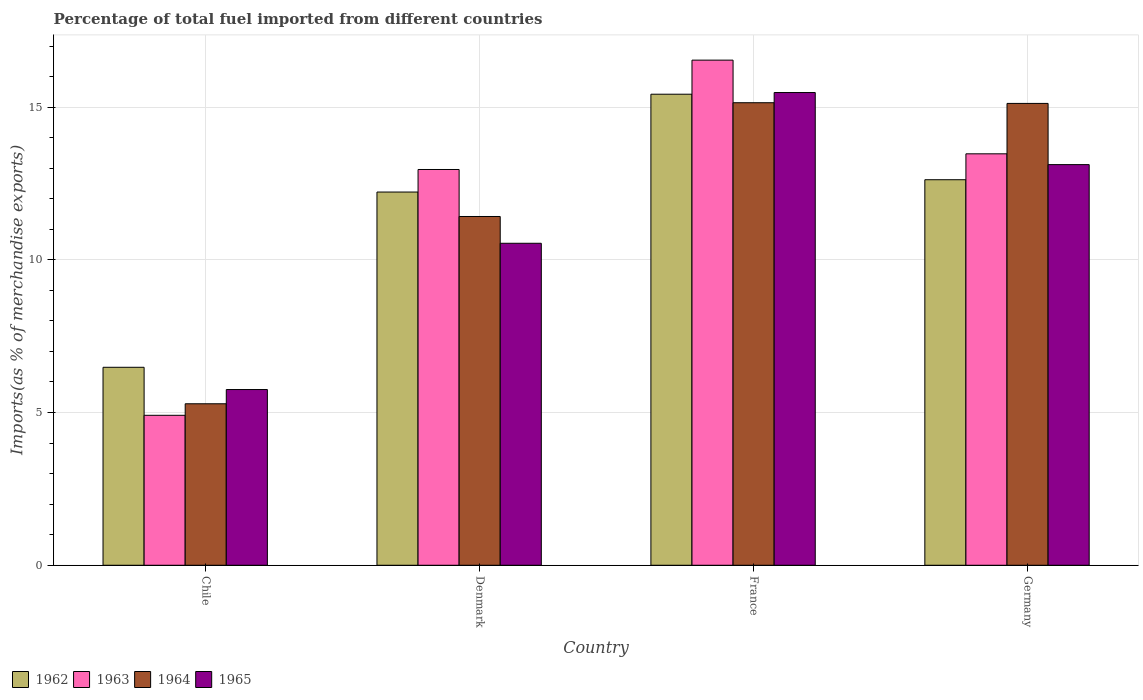How many different coloured bars are there?
Your answer should be compact. 4. How many groups of bars are there?
Provide a short and direct response. 4. How many bars are there on the 1st tick from the left?
Give a very brief answer. 4. What is the label of the 2nd group of bars from the left?
Your response must be concise. Denmark. What is the percentage of imports to different countries in 1965 in Chile?
Ensure brevity in your answer.  5.75. Across all countries, what is the maximum percentage of imports to different countries in 1964?
Provide a short and direct response. 15.14. Across all countries, what is the minimum percentage of imports to different countries in 1964?
Offer a terse response. 5.29. In which country was the percentage of imports to different countries in 1962 maximum?
Offer a very short reply. France. In which country was the percentage of imports to different countries in 1963 minimum?
Keep it short and to the point. Chile. What is the total percentage of imports to different countries in 1964 in the graph?
Offer a very short reply. 46.97. What is the difference between the percentage of imports to different countries in 1964 in Chile and that in France?
Your answer should be very brief. -9.86. What is the difference between the percentage of imports to different countries in 1965 in France and the percentage of imports to different countries in 1964 in Chile?
Offer a terse response. 10.19. What is the average percentage of imports to different countries in 1963 per country?
Offer a terse response. 11.97. What is the difference between the percentage of imports to different countries of/in 1964 and percentage of imports to different countries of/in 1963 in Germany?
Your response must be concise. 1.65. In how many countries, is the percentage of imports to different countries in 1962 greater than 2 %?
Your response must be concise. 4. What is the ratio of the percentage of imports to different countries in 1962 in Denmark to that in Germany?
Provide a short and direct response. 0.97. What is the difference between the highest and the second highest percentage of imports to different countries in 1963?
Give a very brief answer. 3.58. What is the difference between the highest and the lowest percentage of imports to different countries in 1962?
Your response must be concise. 8.94. In how many countries, is the percentage of imports to different countries in 1963 greater than the average percentage of imports to different countries in 1963 taken over all countries?
Ensure brevity in your answer.  3. Is the sum of the percentage of imports to different countries in 1965 in Chile and France greater than the maximum percentage of imports to different countries in 1964 across all countries?
Provide a short and direct response. Yes. What does the 1st bar from the left in France represents?
Provide a succinct answer. 1962. What does the 2nd bar from the right in Germany represents?
Make the answer very short. 1964. Is it the case that in every country, the sum of the percentage of imports to different countries in 1962 and percentage of imports to different countries in 1964 is greater than the percentage of imports to different countries in 1965?
Give a very brief answer. Yes. How many bars are there?
Offer a very short reply. 16. Are all the bars in the graph horizontal?
Make the answer very short. No. How many countries are there in the graph?
Your answer should be compact. 4. Does the graph contain any zero values?
Keep it short and to the point. No. Does the graph contain grids?
Provide a succinct answer. Yes. Where does the legend appear in the graph?
Your answer should be compact. Bottom left. How are the legend labels stacked?
Your answer should be compact. Horizontal. What is the title of the graph?
Provide a succinct answer. Percentage of total fuel imported from different countries. Does "1974" appear as one of the legend labels in the graph?
Offer a very short reply. No. What is the label or title of the X-axis?
Offer a very short reply. Country. What is the label or title of the Y-axis?
Your answer should be very brief. Imports(as % of merchandise exports). What is the Imports(as % of merchandise exports) in 1962 in Chile?
Your answer should be compact. 6.48. What is the Imports(as % of merchandise exports) in 1963 in Chile?
Offer a very short reply. 4.91. What is the Imports(as % of merchandise exports) in 1964 in Chile?
Your answer should be very brief. 5.29. What is the Imports(as % of merchandise exports) of 1965 in Chile?
Make the answer very short. 5.75. What is the Imports(as % of merchandise exports) in 1962 in Denmark?
Provide a succinct answer. 12.22. What is the Imports(as % of merchandise exports) of 1963 in Denmark?
Ensure brevity in your answer.  12.96. What is the Imports(as % of merchandise exports) of 1964 in Denmark?
Offer a very short reply. 11.42. What is the Imports(as % of merchandise exports) of 1965 in Denmark?
Your response must be concise. 10.54. What is the Imports(as % of merchandise exports) of 1962 in France?
Give a very brief answer. 15.42. What is the Imports(as % of merchandise exports) in 1963 in France?
Ensure brevity in your answer.  16.54. What is the Imports(as % of merchandise exports) in 1964 in France?
Ensure brevity in your answer.  15.14. What is the Imports(as % of merchandise exports) in 1965 in France?
Your answer should be compact. 15.48. What is the Imports(as % of merchandise exports) of 1962 in Germany?
Offer a very short reply. 12.62. What is the Imports(as % of merchandise exports) of 1963 in Germany?
Keep it short and to the point. 13.47. What is the Imports(as % of merchandise exports) of 1964 in Germany?
Make the answer very short. 15.12. What is the Imports(as % of merchandise exports) of 1965 in Germany?
Keep it short and to the point. 13.12. Across all countries, what is the maximum Imports(as % of merchandise exports) in 1962?
Offer a very short reply. 15.42. Across all countries, what is the maximum Imports(as % of merchandise exports) in 1963?
Your response must be concise. 16.54. Across all countries, what is the maximum Imports(as % of merchandise exports) in 1964?
Ensure brevity in your answer.  15.14. Across all countries, what is the maximum Imports(as % of merchandise exports) in 1965?
Offer a terse response. 15.48. Across all countries, what is the minimum Imports(as % of merchandise exports) in 1962?
Offer a very short reply. 6.48. Across all countries, what is the minimum Imports(as % of merchandise exports) of 1963?
Keep it short and to the point. 4.91. Across all countries, what is the minimum Imports(as % of merchandise exports) in 1964?
Provide a succinct answer. 5.29. Across all countries, what is the minimum Imports(as % of merchandise exports) of 1965?
Your response must be concise. 5.75. What is the total Imports(as % of merchandise exports) in 1962 in the graph?
Offer a terse response. 46.75. What is the total Imports(as % of merchandise exports) of 1963 in the graph?
Offer a very short reply. 47.88. What is the total Imports(as % of merchandise exports) of 1964 in the graph?
Give a very brief answer. 46.97. What is the total Imports(as % of merchandise exports) in 1965 in the graph?
Offer a very short reply. 44.89. What is the difference between the Imports(as % of merchandise exports) of 1962 in Chile and that in Denmark?
Provide a succinct answer. -5.74. What is the difference between the Imports(as % of merchandise exports) of 1963 in Chile and that in Denmark?
Your answer should be compact. -8.05. What is the difference between the Imports(as % of merchandise exports) in 1964 in Chile and that in Denmark?
Your answer should be compact. -6.13. What is the difference between the Imports(as % of merchandise exports) in 1965 in Chile and that in Denmark?
Make the answer very short. -4.79. What is the difference between the Imports(as % of merchandise exports) of 1962 in Chile and that in France?
Ensure brevity in your answer.  -8.94. What is the difference between the Imports(as % of merchandise exports) of 1963 in Chile and that in France?
Give a very brief answer. -11.63. What is the difference between the Imports(as % of merchandise exports) in 1964 in Chile and that in France?
Your answer should be compact. -9.86. What is the difference between the Imports(as % of merchandise exports) of 1965 in Chile and that in France?
Your response must be concise. -9.72. What is the difference between the Imports(as % of merchandise exports) of 1962 in Chile and that in Germany?
Provide a succinct answer. -6.14. What is the difference between the Imports(as % of merchandise exports) in 1963 in Chile and that in Germany?
Provide a short and direct response. -8.56. What is the difference between the Imports(as % of merchandise exports) in 1964 in Chile and that in Germany?
Offer a terse response. -9.83. What is the difference between the Imports(as % of merchandise exports) in 1965 in Chile and that in Germany?
Offer a very short reply. -7.36. What is the difference between the Imports(as % of merchandise exports) of 1962 in Denmark and that in France?
Offer a terse response. -3.2. What is the difference between the Imports(as % of merchandise exports) in 1963 in Denmark and that in France?
Give a very brief answer. -3.58. What is the difference between the Imports(as % of merchandise exports) of 1964 in Denmark and that in France?
Provide a short and direct response. -3.72. What is the difference between the Imports(as % of merchandise exports) in 1965 in Denmark and that in France?
Offer a terse response. -4.94. What is the difference between the Imports(as % of merchandise exports) of 1962 in Denmark and that in Germany?
Your response must be concise. -0.4. What is the difference between the Imports(as % of merchandise exports) in 1963 in Denmark and that in Germany?
Provide a succinct answer. -0.51. What is the difference between the Imports(as % of merchandise exports) of 1964 in Denmark and that in Germany?
Give a very brief answer. -3.7. What is the difference between the Imports(as % of merchandise exports) in 1965 in Denmark and that in Germany?
Keep it short and to the point. -2.58. What is the difference between the Imports(as % of merchandise exports) of 1962 in France and that in Germany?
Provide a short and direct response. 2.8. What is the difference between the Imports(as % of merchandise exports) in 1963 in France and that in Germany?
Provide a short and direct response. 3.07. What is the difference between the Imports(as % of merchandise exports) in 1964 in France and that in Germany?
Your answer should be very brief. 0.02. What is the difference between the Imports(as % of merchandise exports) in 1965 in France and that in Germany?
Provide a succinct answer. 2.36. What is the difference between the Imports(as % of merchandise exports) in 1962 in Chile and the Imports(as % of merchandise exports) in 1963 in Denmark?
Your response must be concise. -6.48. What is the difference between the Imports(as % of merchandise exports) of 1962 in Chile and the Imports(as % of merchandise exports) of 1964 in Denmark?
Provide a short and direct response. -4.94. What is the difference between the Imports(as % of merchandise exports) in 1962 in Chile and the Imports(as % of merchandise exports) in 1965 in Denmark?
Provide a succinct answer. -4.06. What is the difference between the Imports(as % of merchandise exports) of 1963 in Chile and the Imports(as % of merchandise exports) of 1964 in Denmark?
Give a very brief answer. -6.51. What is the difference between the Imports(as % of merchandise exports) of 1963 in Chile and the Imports(as % of merchandise exports) of 1965 in Denmark?
Ensure brevity in your answer.  -5.63. What is the difference between the Imports(as % of merchandise exports) of 1964 in Chile and the Imports(as % of merchandise exports) of 1965 in Denmark?
Your answer should be compact. -5.25. What is the difference between the Imports(as % of merchandise exports) in 1962 in Chile and the Imports(as % of merchandise exports) in 1963 in France?
Give a very brief answer. -10.06. What is the difference between the Imports(as % of merchandise exports) of 1962 in Chile and the Imports(as % of merchandise exports) of 1964 in France?
Your answer should be compact. -8.66. What is the difference between the Imports(as % of merchandise exports) of 1962 in Chile and the Imports(as % of merchandise exports) of 1965 in France?
Provide a succinct answer. -9. What is the difference between the Imports(as % of merchandise exports) in 1963 in Chile and the Imports(as % of merchandise exports) in 1964 in France?
Keep it short and to the point. -10.23. What is the difference between the Imports(as % of merchandise exports) in 1963 in Chile and the Imports(as % of merchandise exports) in 1965 in France?
Your answer should be very brief. -10.57. What is the difference between the Imports(as % of merchandise exports) of 1964 in Chile and the Imports(as % of merchandise exports) of 1965 in France?
Make the answer very short. -10.19. What is the difference between the Imports(as % of merchandise exports) of 1962 in Chile and the Imports(as % of merchandise exports) of 1963 in Germany?
Keep it short and to the point. -6.99. What is the difference between the Imports(as % of merchandise exports) of 1962 in Chile and the Imports(as % of merchandise exports) of 1964 in Germany?
Your answer should be very brief. -8.64. What is the difference between the Imports(as % of merchandise exports) in 1962 in Chile and the Imports(as % of merchandise exports) in 1965 in Germany?
Provide a succinct answer. -6.64. What is the difference between the Imports(as % of merchandise exports) in 1963 in Chile and the Imports(as % of merchandise exports) in 1964 in Germany?
Your answer should be very brief. -10.21. What is the difference between the Imports(as % of merchandise exports) in 1963 in Chile and the Imports(as % of merchandise exports) in 1965 in Germany?
Keep it short and to the point. -8.21. What is the difference between the Imports(as % of merchandise exports) in 1964 in Chile and the Imports(as % of merchandise exports) in 1965 in Germany?
Your answer should be compact. -7.83. What is the difference between the Imports(as % of merchandise exports) in 1962 in Denmark and the Imports(as % of merchandise exports) in 1963 in France?
Ensure brevity in your answer.  -4.32. What is the difference between the Imports(as % of merchandise exports) in 1962 in Denmark and the Imports(as % of merchandise exports) in 1964 in France?
Ensure brevity in your answer.  -2.92. What is the difference between the Imports(as % of merchandise exports) in 1962 in Denmark and the Imports(as % of merchandise exports) in 1965 in France?
Offer a terse response. -3.26. What is the difference between the Imports(as % of merchandise exports) of 1963 in Denmark and the Imports(as % of merchandise exports) of 1964 in France?
Your response must be concise. -2.19. What is the difference between the Imports(as % of merchandise exports) in 1963 in Denmark and the Imports(as % of merchandise exports) in 1965 in France?
Your response must be concise. -2.52. What is the difference between the Imports(as % of merchandise exports) in 1964 in Denmark and the Imports(as % of merchandise exports) in 1965 in France?
Ensure brevity in your answer.  -4.06. What is the difference between the Imports(as % of merchandise exports) of 1962 in Denmark and the Imports(as % of merchandise exports) of 1963 in Germany?
Your answer should be compact. -1.25. What is the difference between the Imports(as % of merchandise exports) of 1962 in Denmark and the Imports(as % of merchandise exports) of 1964 in Germany?
Offer a very short reply. -2.9. What is the difference between the Imports(as % of merchandise exports) in 1962 in Denmark and the Imports(as % of merchandise exports) in 1965 in Germany?
Your answer should be compact. -0.9. What is the difference between the Imports(as % of merchandise exports) of 1963 in Denmark and the Imports(as % of merchandise exports) of 1964 in Germany?
Make the answer very short. -2.16. What is the difference between the Imports(as % of merchandise exports) in 1963 in Denmark and the Imports(as % of merchandise exports) in 1965 in Germany?
Make the answer very short. -0.16. What is the difference between the Imports(as % of merchandise exports) in 1964 in Denmark and the Imports(as % of merchandise exports) in 1965 in Germany?
Offer a terse response. -1.7. What is the difference between the Imports(as % of merchandise exports) of 1962 in France and the Imports(as % of merchandise exports) of 1963 in Germany?
Ensure brevity in your answer.  1.95. What is the difference between the Imports(as % of merchandise exports) of 1962 in France and the Imports(as % of merchandise exports) of 1964 in Germany?
Offer a very short reply. 0.3. What is the difference between the Imports(as % of merchandise exports) in 1962 in France and the Imports(as % of merchandise exports) in 1965 in Germany?
Your response must be concise. 2.31. What is the difference between the Imports(as % of merchandise exports) in 1963 in France and the Imports(as % of merchandise exports) in 1964 in Germany?
Make the answer very short. 1.42. What is the difference between the Imports(as % of merchandise exports) in 1963 in France and the Imports(as % of merchandise exports) in 1965 in Germany?
Provide a succinct answer. 3.42. What is the difference between the Imports(as % of merchandise exports) in 1964 in France and the Imports(as % of merchandise exports) in 1965 in Germany?
Give a very brief answer. 2.03. What is the average Imports(as % of merchandise exports) of 1962 per country?
Offer a terse response. 11.69. What is the average Imports(as % of merchandise exports) of 1963 per country?
Your answer should be compact. 11.97. What is the average Imports(as % of merchandise exports) of 1964 per country?
Your answer should be very brief. 11.74. What is the average Imports(as % of merchandise exports) of 1965 per country?
Your answer should be very brief. 11.22. What is the difference between the Imports(as % of merchandise exports) of 1962 and Imports(as % of merchandise exports) of 1963 in Chile?
Your answer should be very brief. 1.57. What is the difference between the Imports(as % of merchandise exports) of 1962 and Imports(as % of merchandise exports) of 1964 in Chile?
Give a very brief answer. 1.19. What is the difference between the Imports(as % of merchandise exports) in 1962 and Imports(as % of merchandise exports) in 1965 in Chile?
Keep it short and to the point. 0.73. What is the difference between the Imports(as % of merchandise exports) in 1963 and Imports(as % of merchandise exports) in 1964 in Chile?
Offer a terse response. -0.38. What is the difference between the Imports(as % of merchandise exports) of 1963 and Imports(as % of merchandise exports) of 1965 in Chile?
Provide a succinct answer. -0.84. What is the difference between the Imports(as % of merchandise exports) in 1964 and Imports(as % of merchandise exports) in 1965 in Chile?
Offer a very short reply. -0.47. What is the difference between the Imports(as % of merchandise exports) of 1962 and Imports(as % of merchandise exports) of 1963 in Denmark?
Provide a succinct answer. -0.74. What is the difference between the Imports(as % of merchandise exports) of 1962 and Imports(as % of merchandise exports) of 1964 in Denmark?
Your answer should be compact. 0.8. What is the difference between the Imports(as % of merchandise exports) of 1962 and Imports(as % of merchandise exports) of 1965 in Denmark?
Offer a terse response. 1.68. What is the difference between the Imports(as % of merchandise exports) in 1963 and Imports(as % of merchandise exports) in 1964 in Denmark?
Offer a terse response. 1.54. What is the difference between the Imports(as % of merchandise exports) in 1963 and Imports(as % of merchandise exports) in 1965 in Denmark?
Provide a short and direct response. 2.42. What is the difference between the Imports(as % of merchandise exports) of 1964 and Imports(as % of merchandise exports) of 1965 in Denmark?
Your response must be concise. 0.88. What is the difference between the Imports(as % of merchandise exports) in 1962 and Imports(as % of merchandise exports) in 1963 in France?
Keep it short and to the point. -1.12. What is the difference between the Imports(as % of merchandise exports) in 1962 and Imports(as % of merchandise exports) in 1964 in France?
Provide a short and direct response. 0.28. What is the difference between the Imports(as % of merchandise exports) in 1962 and Imports(as % of merchandise exports) in 1965 in France?
Ensure brevity in your answer.  -0.05. What is the difference between the Imports(as % of merchandise exports) of 1963 and Imports(as % of merchandise exports) of 1964 in France?
Ensure brevity in your answer.  1.39. What is the difference between the Imports(as % of merchandise exports) in 1963 and Imports(as % of merchandise exports) in 1965 in France?
Your answer should be compact. 1.06. What is the difference between the Imports(as % of merchandise exports) in 1964 and Imports(as % of merchandise exports) in 1965 in France?
Provide a succinct answer. -0.33. What is the difference between the Imports(as % of merchandise exports) in 1962 and Imports(as % of merchandise exports) in 1963 in Germany?
Keep it short and to the point. -0.85. What is the difference between the Imports(as % of merchandise exports) in 1962 and Imports(as % of merchandise exports) in 1964 in Germany?
Your answer should be compact. -2.5. What is the difference between the Imports(as % of merchandise exports) of 1962 and Imports(as % of merchandise exports) of 1965 in Germany?
Your answer should be compact. -0.49. What is the difference between the Imports(as % of merchandise exports) of 1963 and Imports(as % of merchandise exports) of 1964 in Germany?
Keep it short and to the point. -1.65. What is the difference between the Imports(as % of merchandise exports) in 1963 and Imports(as % of merchandise exports) in 1965 in Germany?
Your answer should be compact. 0.35. What is the difference between the Imports(as % of merchandise exports) in 1964 and Imports(as % of merchandise exports) in 1965 in Germany?
Ensure brevity in your answer.  2. What is the ratio of the Imports(as % of merchandise exports) of 1962 in Chile to that in Denmark?
Make the answer very short. 0.53. What is the ratio of the Imports(as % of merchandise exports) in 1963 in Chile to that in Denmark?
Make the answer very short. 0.38. What is the ratio of the Imports(as % of merchandise exports) in 1964 in Chile to that in Denmark?
Your response must be concise. 0.46. What is the ratio of the Imports(as % of merchandise exports) in 1965 in Chile to that in Denmark?
Your answer should be compact. 0.55. What is the ratio of the Imports(as % of merchandise exports) of 1962 in Chile to that in France?
Give a very brief answer. 0.42. What is the ratio of the Imports(as % of merchandise exports) of 1963 in Chile to that in France?
Your answer should be very brief. 0.3. What is the ratio of the Imports(as % of merchandise exports) in 1964 in Chile to that in France?
Make the answer very short. 0.35. What is the ratio of the Imports(as % of merchandise exports) of 1965 in Chile to that in France?
Your response must be concise. 0.37. What is the ratio of the Imports(as % of merchandise exports) in 1962 in Chile to that in Germany?
Your answer should be very brief. 0.51. What is the ratio of the Imports(as % of merchandise exports) of 1963 in Chile to that in Germany?
Provide a short and direct response. 0.36. What is the ratio of the Imports(as % of merchandise exports) of 1964 in Chile to that in Germany?
Give a very brief answer. 0.35. What is the ratio of the Imports(as % of merchandise exports) in 1965 in Chile to that in Germany?
Your answer should be very brief. 0.44. What is the ratio of the Imports(as % of merchandise exports) of 1962 in Denmark to that in France?
Ensure brevity in your answer.  0.79. What is the ratio of the Imports(as % of merchandise exports) of 1963 in Denmark to that in France?
Your response must be concise. 0.78. What is the ratio of the Imports(as % of merchandise exports) in 1964 in Denmark to that in France?
Offer a very short reply. 0.75. What is the ratio of the Imports(as % of merchandise exports) of 1965 in Denmark to that in France?
Provide a short and direct response. 0.68. What is the ratio of the Imports(as % of merchandise exports) of 1962 in Denmark to that in Germany?
Make the answer very short. 0.97. What is the ratio of the Imports(as % of merchandise exports) of 1963 in Denmark to that in Germany?
Your response must be concise. 0.96. What is the ratio of the Imports(as % of merchandise exports) in 1964 in Denmark to that in Germany?
Your response must be concise. 0.76. What is the ratio of the Imports(as % of merchandise exports) of 1965 in Denmark to that in Germany?
Your answer should be compact. 0.8. What is the ratio of the Imports(as % of merchandise exports) in 1962 in France to that in Germany?
Keep it short and to the point. 1.22. What is the ratio of the Imports(as % of merchandise exports) in 1963 in France to that in Germany?
Your answer should be very brief. 1.23. What is the ratio of the Imports(as % of merchandise exports) in 1965 in France to that in Germany?
Your response must be concise. 1.18. What is the difference between the highest and the second highest Imports(as % of merchandise exports) of 1962?
Your answer should be very brief. 2.8. What is the difference between the highest and the second highest Imports(as % of merchandise exports) of 1963?
Provide a succinct answer. 3.07. What is the difference between the highest and the second highest Imports(as % of merchandise exports) in 1964?
Provide a succinct answer. 0.02. What is the difference between the highest and the second highest Imports(as % of merchandise exports) in 1965?
Your answer should be very brief. 2.36. What is the difference between the highest and the lowest Imports(as % of merchandise exports) of 1962?
Make the answer very short. 8.94. What is the difference between the highest and the lowest Imports(as % of merchandise exports) in 1963?
Provide a short and direct response. 11.63. What is the difference between the highest and the lowest Imports(as % of merchandise exports) of 1964?
Ensure brevity in your answer.  9.86. What is the difference between the highest and the lowest Imports(as % of merchandise exports) of 1965?
Provide a succinct answer. 9.72. 